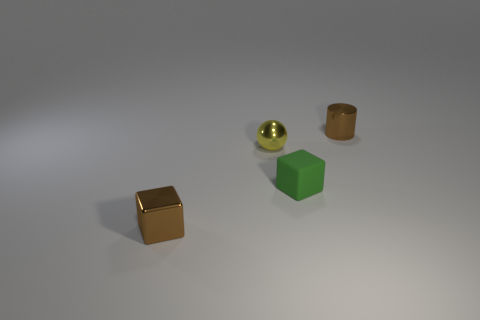Add 4 green metallic cubes. How many objects exist? 8 Subtract all spheres. How many objects are left? 3 Add 3 small brown shiny cylinders. How many small brown shiny cylinders exist? 4 Subtract 0 red cubes. How many objects are left? 4 Subtract all green things. Subtract all shiny objects. How many objects are left? 0 Add 1 yellow objects. How many yellow objects are left? 2 